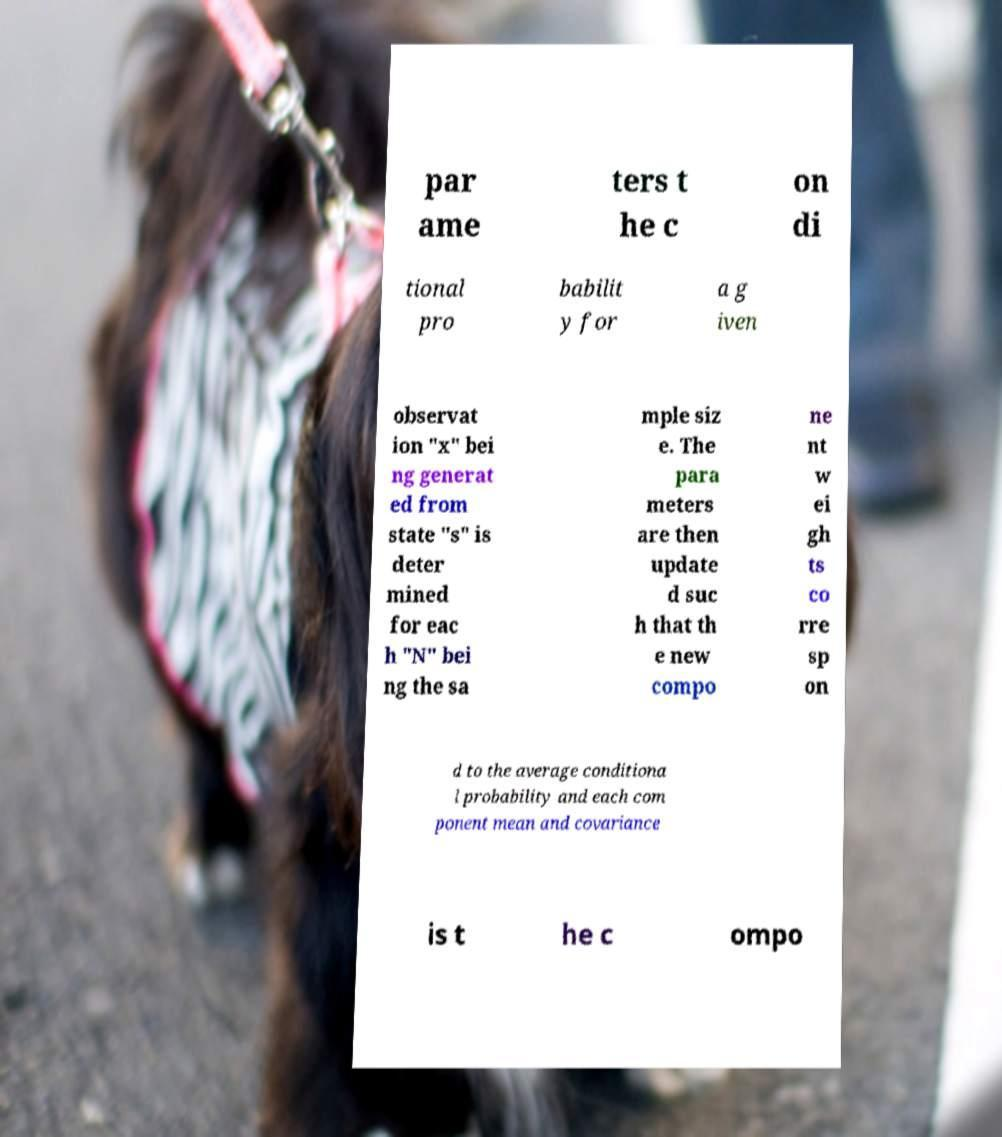There's text embedded in this image that I need extracted. Can you transcribe it verbatim? par ame ters t he c on di tional pro babilit y for a g iven observat ion "x" bei ng generat ed from state "s" is deter mined for eac h "N" bei ng the sa mple siz e. The para meters are then update d suc h that th e new compo ne nt w ei gh ts co rre sp on d to the average conditiona l probability and each com ponent mean and covariance is t he c ompo 